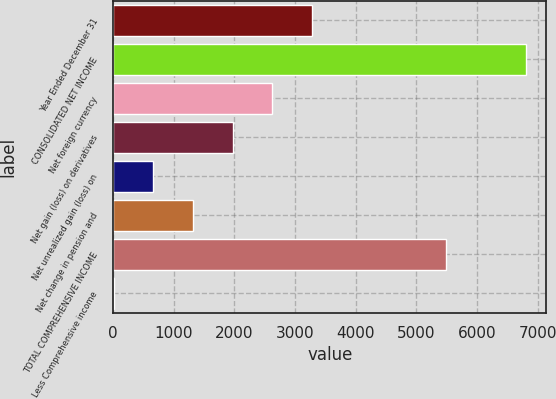<chart> <loc_0><loc_0><loc_500><loc_500><bar_chart><fcel>Year Ended December 31<fcel>CONSOLIDATED NET INCOME<fcel>Net foreign currency<fcel>Net gain (loss) on derivatives<fcel>Net unrealized gain (loss) on<fcel>Net change in pension and<fcel>TOTAL COMPREHENSIVE INCOME<fcel>Less Comprehensive income<nl><fcel>3280<fcel>6804<fcel>2626<fcel>1972<fcel>664<fcel>1318<fcel>5496<fcel>10<nl></chart> 